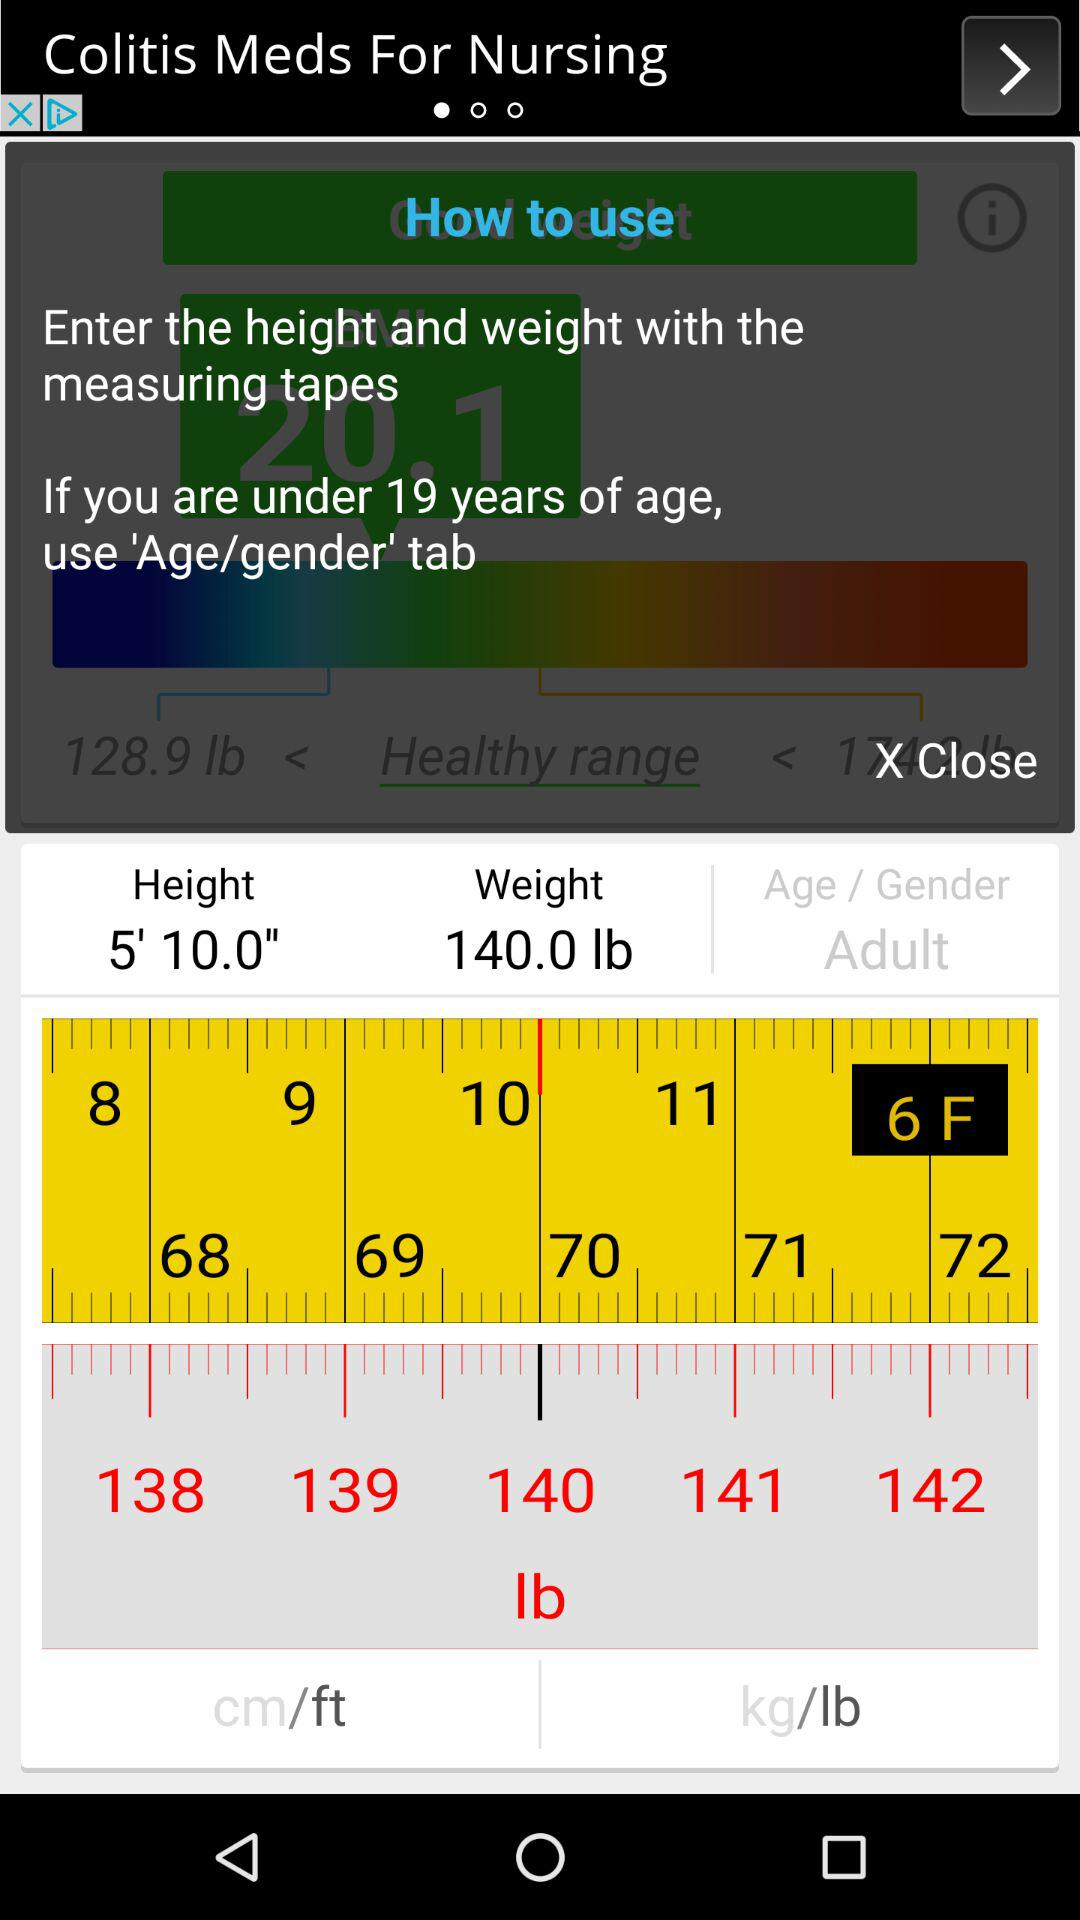What is the height? The height is 5 feet 10 inches. 